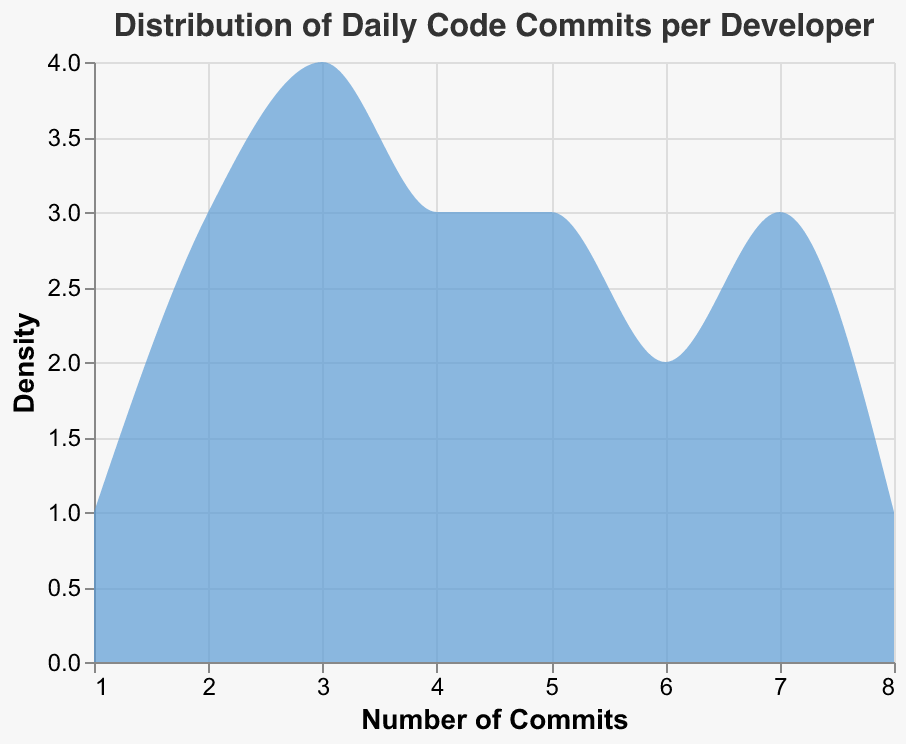What's the title of the chart? The title is displayed at the top of the chart and reads "Distribution of Daily Code Commits per Developer".
Answer: Distribution of Daily Code Commits per Developer What is the x-axis representing? The x-axis shows the "Number of Commits," indicating the number of code commits made by each developer.
Answer: Number of Commits What is the y-axis representing? The y-axis represents "Density," indicating the count of developers for each number of commits.
Answer: Density How many developers have committed 3 times? By looking at the density plot, we count the peak height for the value 3 on the x-axis, which corresponds to the number of developers. There are 4 developers with 3 commits.
Answer: 4 Which commit frequency has the highest density? The highest density is observed around 3 commits on the x-axis. This indicates that the commit frequency of 3 has the highest number of developers.
Answer: 3 How many developers have committed more than 5 times? To find this, we sum the number of developers for commit frequencies greater than 5 (6, 7, 8). There are 3 developers (6) + 3 developers (7) + 1 developer (8). Altogether, there are 7 developers.
Answer: 7 Which commit frequency has the lowest density? The lowest density is observed at 1 commit on the x-axis, indicating the fewest number of developers committing only once.
Answer: 1 What is the most common number of commits? The mode is the value that appears most frequently. The peak of the density plot indicates the mode, which is 3 commits.
Answer: 3 What's the range of the number of commits? The range is the difference between the maximum and minimum number of commits observed. The maximum commits are 8 and the minimum is 1, so the range is 8 - 1 = 7.
Answer: 7 What can you infer about the distribution shape? The distribution appears to have a peak around 3 commits and it gradually tapers off on both sides, indicating a unimodal and somewhat symmetric distribution with a longer tail towards higher commits.
Answer: Unimodal and somewhat symmetric 